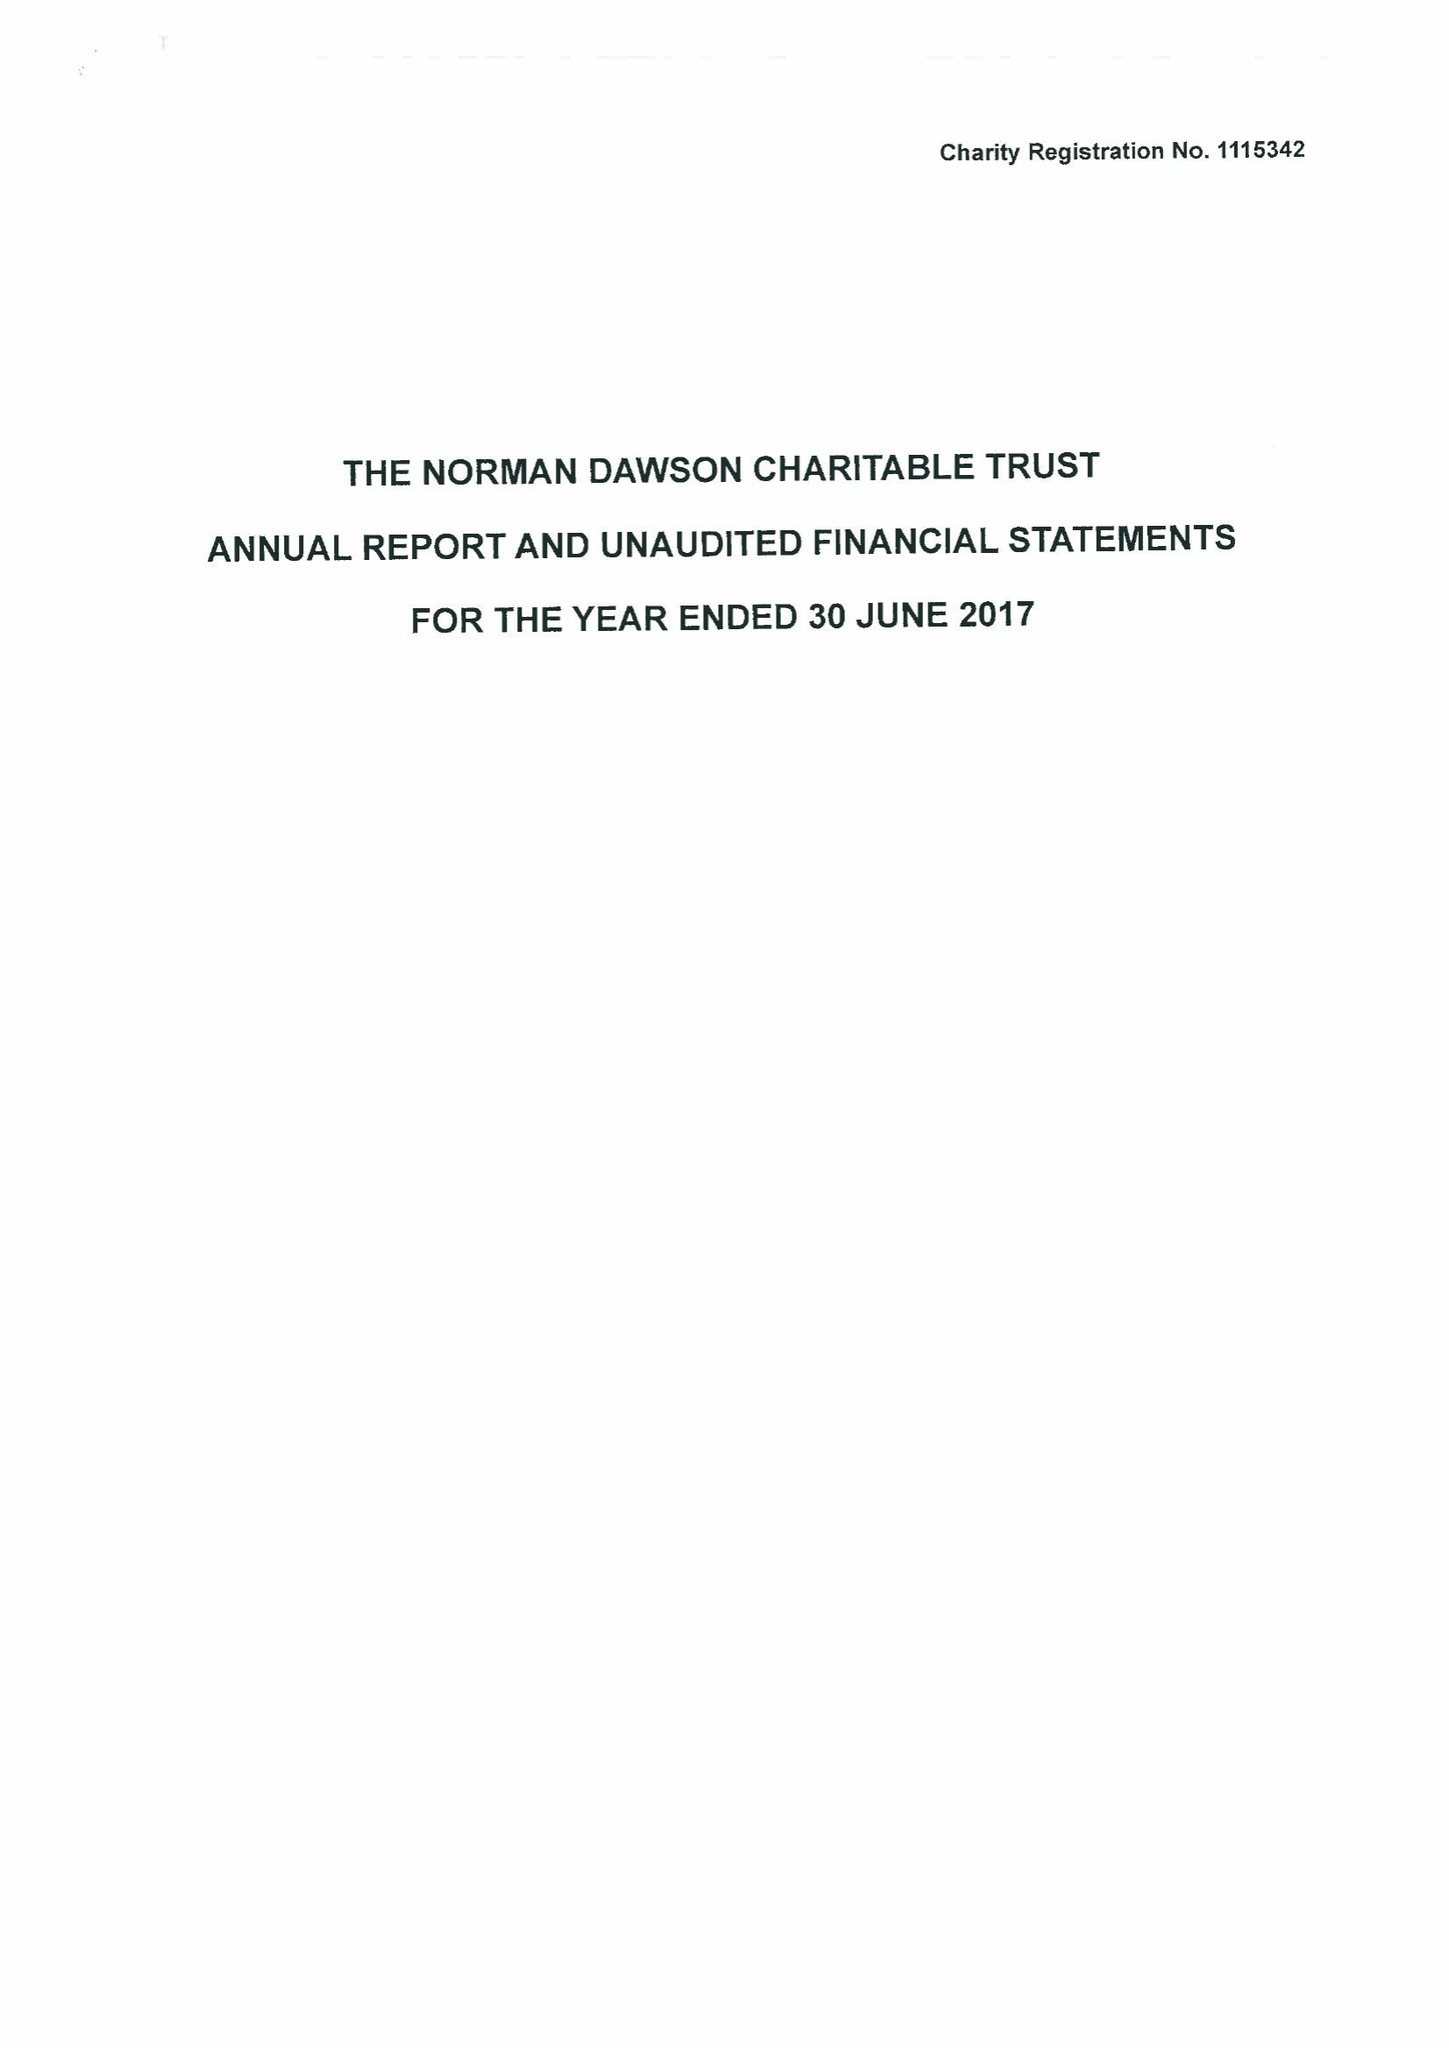What is the value for the address__postcode?
Answer the question using a single word or phrase. DY10 2SA 